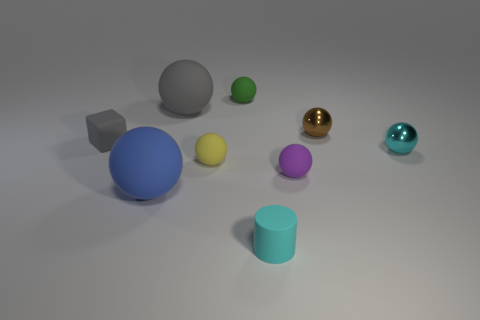Subtract all gray balls. How many balls are left? 6 Subtract all green rubber balls. How many balls are left? 6 Subtract all gray spheres. Subtract all green cubes. How many spheres are left? 6 Subtract all blocks. How many objects are left? 8 Add 1 green objects. How many green objects exist? 2 Subtract 0 red spheres. How many objects are left? 9 Subtract all metallic things. Subtract all green rubber balls. How many objects are left? 6 Add 7 big blue objects. How many big blue objects are left? 8 